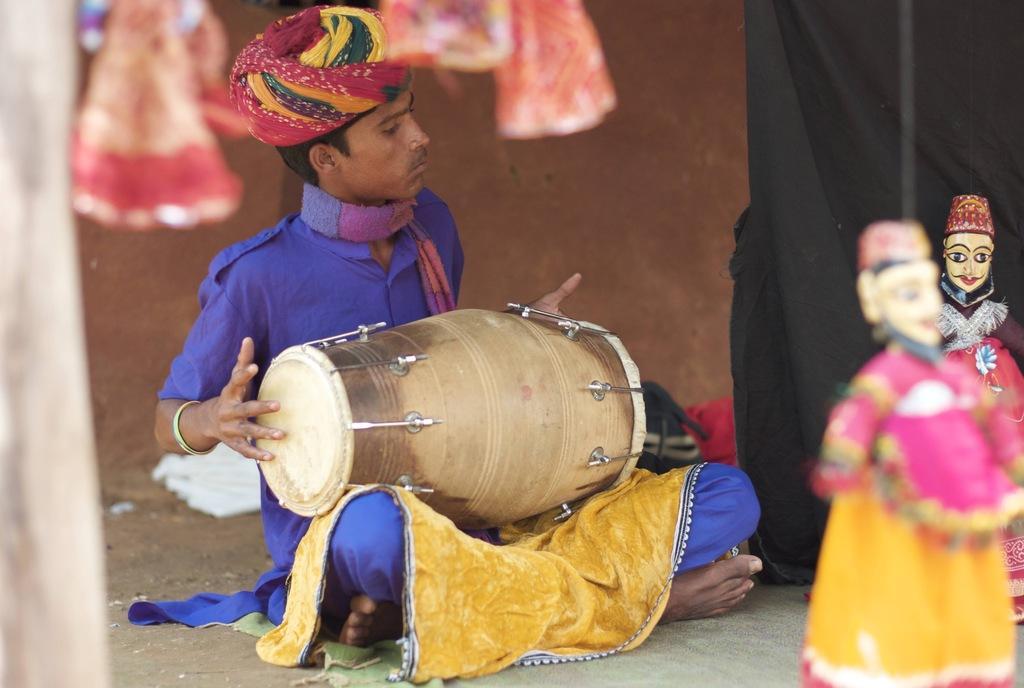In one or two sentences, can you explain what this image depicts? Man playing drum here there are two toys. 